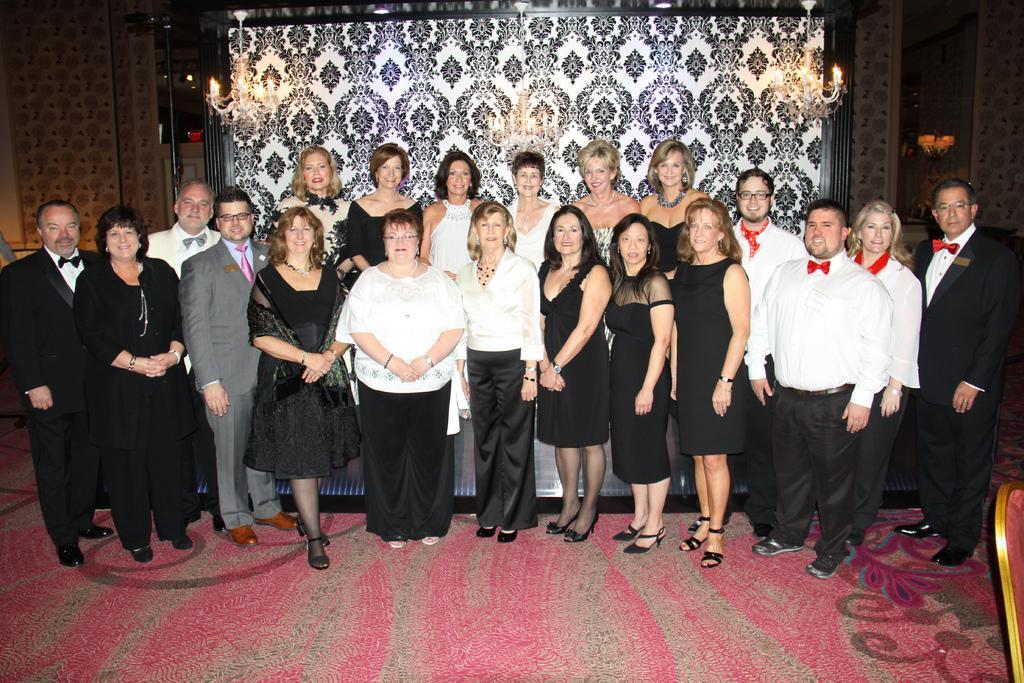Can you describe this image briefly? In the picture we can see group of persons standing in a row and posing for a photograph and in the background of the picture there is screen, there are chandeliers and top of the picture there is roof. 